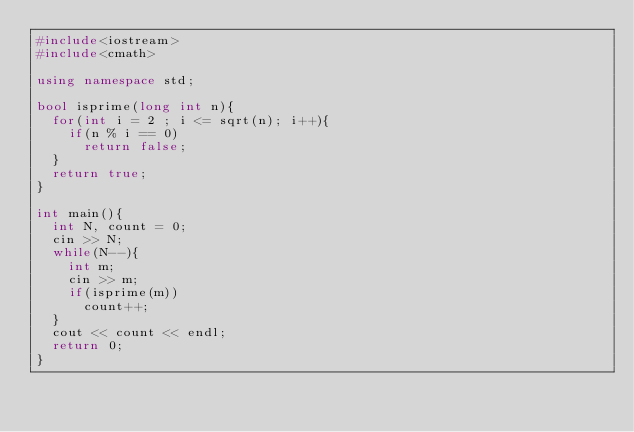Convert code to text. <code><loc_0><loc_0><loc_500><loc_500><_C++_>#include<iostream>
#include<cmath>

using namespace std;

bool isprime(long int n){
  for(int i = 2 ; i <= sqrt(n); i++){
    if(n % i == 0)
      return false;
  }
  return true;
}

int main(){
  int N, count = 0;
  cin >> N;
  while(N--){
    int m;
    cin >> m;
    if(isprime(m))
      count++;
  }
  cout << count << endl;
  return 0;
}</code> 